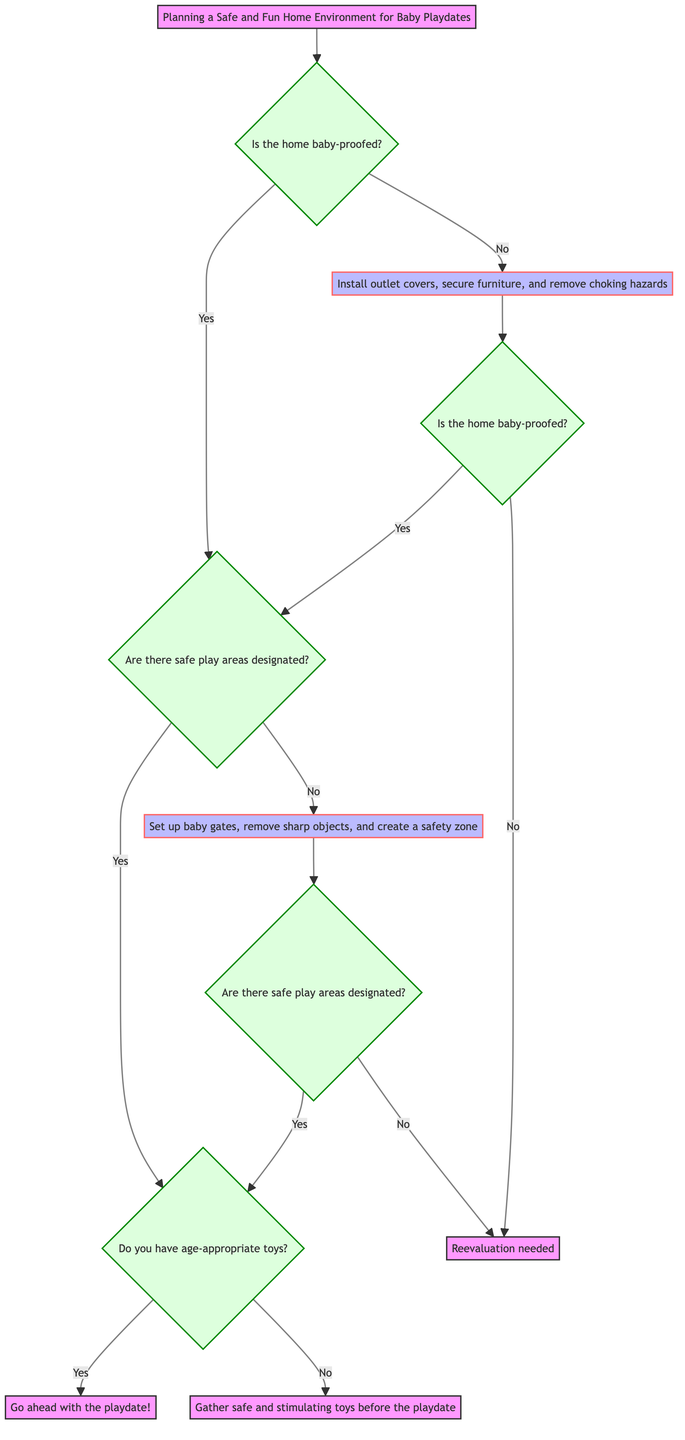What is the first decision point in the diagram? The first decision point is about whether the home is baby-proofed.
Answer: Is the home baby-proofed? What happens if the home is not baby-proofed? If the home is not baby-proofed, the recommendation is to install outlet covers, secure furniture, and remove choking hazards.
Answer: Install outlet covers, secure furniture, and remove choking hazards How many outcomes lead to going ahead with the playdate? There are two outcomes that lead to going ahead with the playdate: both from having safe play areas designated with age-appropriate toys, either from the yes branch of the first decision or after some adjustments.
Answer: Two outcomes What must be done if there are no safe play areas designated? If there are no safe play areas designated, reevaluation is needed.
Answer: Reevaluation needed What is the consequence of having age-appropriate toys and safe play areas? The consequence is to go ahead with the playdate.
Answer: Go ahead with the playdate! What do you need to do if safe play areas are designated but there are no age-appropriate toys? You need to gather safe and stimulating toys before the playdate.
Answer: Gather safe and stimulating toys before the playdate If the home is baby-proofed and there are no designated safe play areas, what is the solution? The solution is to set up baby gates, remove sharp objects, and create a safety zone.
Answer: Set up baby gates, remove sharp objects, and create a safety zone What is the second decision point after the home is checked for baby-proofing? The second decision point checks if there are safe play areas designated.
Answer: Are there safe play areas designated? 